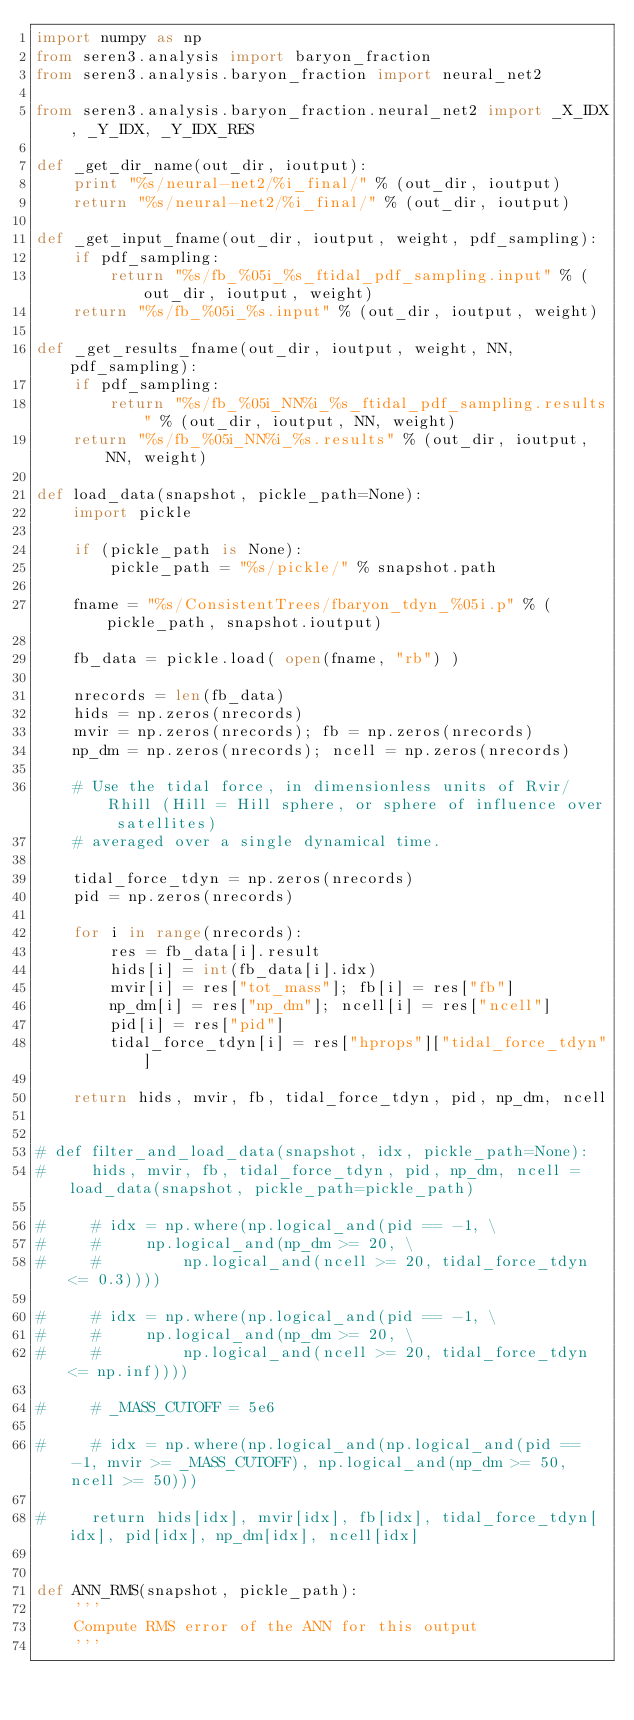Convert code to text. <code><loc_0><loc_0><loc_500><loc_500><_Python_>import numpy as np
from seren3.analysis import baryon_fraction
from seren3.analysis.baryon_fraction import neural_net2

from seren3.analysis.baryon_fraction.neural_net2 import _X_IDX, _Y_IDX, _Y_IDX_RES

def _get_dir_name(out_dir, ioutput):
    print "%s/neural-net2/%i_final/" % (out_dir, ioutput)
    return "%s/neural-net2/%i_final/" % (out_dir, ioutput)

def _get_input_fname(out_dir, ioutput, weight, pdf_sampling):
    if pdf_sampling:
        return "%s/fb_%05i_%s_ftidal_pdf_sampling.input" % (out_dir, ioutput, weight)
    return "%s/fb_%05i_%s.input" % (out_dir, ioutput, weight)

def _get_results_fname(out_dir, ioutput, weight, NN, pdf_sampling):
    if pdf_sampling:
        return "%s/fb_%05i_NN%i_%s_ftidal_pdf_sampling.results" % (out_dir, ioutput, NN, weight)    
    return "%s/fb_%05i_NN%i_%s.results" % (out_dir, ioutput, NN, weight)

def load_data(snapshot, pickle_path=None):
    import pickle

    if (pickle_path is None):
        pickle_path = "%s/pickle/" % snapshot.path

    fname = "%s/ConsistentTrees/fbaryon_tdyn_%05i.p" % (pickle_path, snapshot.ioutput)

    fb_data = pickle.load( open(fname, "rb") )

    nrecords = len(fb_data)
    hids = np.zeros(nrecords)
    mvir = np.zeros(nrecords); fb = np.zeros(nrecords)
    np_dm = np.zeros(nrecords); ncell = np.zeros(nrecords)

    # Use the tidal force, in dimensionless units of Rvir/Rhill (Hill = Hill sphere, or sphere of influence over satellites)
    # averaged over a single dynamical time.

    tidal_force_tdyn = np.zeros(nrecords)
    pid = np.zeros(nrecords)

    for i in range(nrecords):
        res = fb_data[i].result
        hids[i] = int(fb_data[i].idx)
        mvir[i] = res["tot_mass"]; fb[i] = res["fb"]
        np_dm[i] = res["np_dm"]; ncell[i] = res["ncell"]
        pid[i] = res["pid"]
        tidal_force_tdyn[i] = res["hprops"]["tidal_force_tdyn"]

    return hids, mvir, fb, tidal_force_tdyn, pid, np_dm, ncell


# def filter_and_load_data(snapshot, idx, pickle_path=None):
#     hids, mvir, fb, tidal_force_tdyn, pid, np_dm, ncell = load_data(snapshot, pickle_path=pickle_path)

#     # idx = np.where(np.logical_and(pid == -1, \
#     #     np.logical_and(np_dm >= 20, \
#     #         np.logical_and(ncell >= 20, tidal_force_tdyn <= 0.3))))

#     # idx = np.where(np.logical_and(pid == -1, \
#     #     np.logical_and(np_dm >= 20, \
#     #         np.logical_and(ncell >= 20, tidal_force_tdyn <= np.inf))))

#     # _MASS_CUTOFF = 5e6

#     # idx = np.where(np.logical_and(np.logical_and(pid == -1, mvir >= _MASS_CUTOFF), np.logical_and(np_dm >= 50, ncell >= 50)))

#     return hids[idx], mvir[idx], fb[idx], tidal_force_tdyn[idx], pid[idx], np_dm[idx], ncell[idx]


def ANN_RMS(snapshot, pickle_path):
    '''
    Compute RMS error of the ANN for this output
    '''</code> 